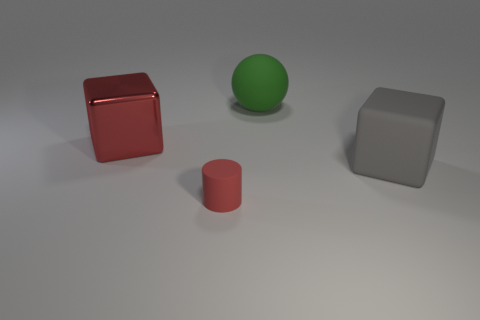Is the size of the thing that is to the left of the small object the same as the rubber thing that is behind the big gray cube?
Keep it short and to the point. Yes. Are there an equal number of red rubber objects that are to the right of the large green object and big things that are behind the big red block?
Provide a succinct answer. No. Are there any other things that have the same material as the large red object?
Your response must be concise. No. Does the gray matte cube have the same size as the red thing that is right of the metallic thing?
Give a very brief answer. No. What material is the red object in front of the big object right of the green thing?
Your response must be concise. Rubber. Are there an equal number of large gray blocks that are on the left side of the gray block and green objects?
Your response must be concise. No. What size is the object that is in front of the large metal block and on the left side of the big sphere?
Make the answer very short. Small. The big ball to the left of the cube that is on the right side of the big rubber sphere is what color?
Your answer should be very brief. Green. How many red things are metallic things or rubber balls?
Ensure brevity in your answer.  1. The big object that is both in front of the sphere and right of the large red metallic block is what color?
Provide a succinct answer. Gray. 